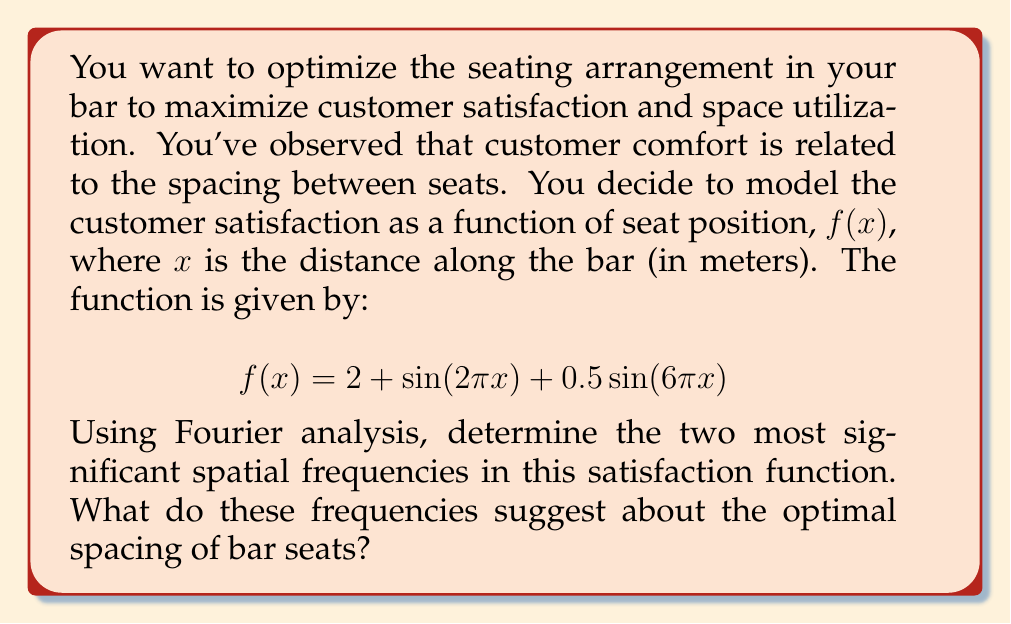Could you help me with this problem? To solve this problem, we need to analyze the given function using Fourier transform concepts. Let's break it down step by step:

1) The given function is:
   $$f(x) = 2 + \sin(2\pi x) + 0.5\sin(6\pi x)$$

2) In Fourier analysis, we're interested in the frequencies of the sinusoidal components. The general form of a sinusoid is $\sin(2\pi fx)$, where $f$ is the frequency.

3) Looking at our function, we can identify two sinusoidal components:
   - $\sin(2\pi x)$
   - $0.5\sin(6\pi x)$

4) For the first component, $\sin(2\pi x)$:
   The frequency is 1 cycle per meter (1 m^-1), as $2\pi * 1 = 2\pi$.

5) For the second component, $0.5\sin(6\pi x)$:
   The frequency is 3 cycles per meter (3 m^-1), as $2\pi * 3 = 6\pi$.

6) The amplitudes of these components are:
   - 1 for the 1 m^-1 frequency
   - 0.5 for the 3 m^-1 frequency

7) Therefore, the two most significant spatial frequencies are 1 m^-1 and 3 m^-1, with the 1 m^-1 frequency being more significant due to its larger amplitude.

8) Interpreting these frequencies:
   - The 1 m^-1 frequency suggests a major satisfaction peak every 1 meter.
   - The 3 m^-1 frequency suggests a minor satisfaction peak every 1/3 meter.

9) For optimal seating, we should primarily consider the 1 m^-1 frequency, as it has a larger impact on customer satisfaction. This suggests that optimal seat spacing should be around 1 meter apart.

10) The 3 m^-1 frequency could be used for fine-tuning the arrangement, possibly by slightly adjusting some seats within the 1-meter spacing to hit the minor satisfaction peaks.
Answer: The two most significant spatial frequencies are 1 m^-1 and 3 m^-1. This suggests that the optimal spacing for bar seats is primarily 1 meter apart, with potential for minor adjustments at 1/3 meter intervals for fine-tuning the arrangement. 